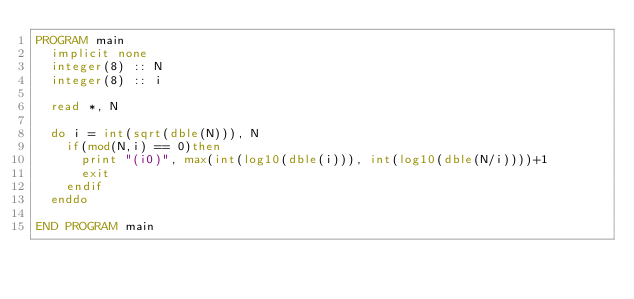Convert code to text. <code><loc_0><loc_0><loc_500><loc_500><_FORTRAN_>PROGRAM main
  implicit none
  integer(8) :: N
  integer(8) :: i
  
  read *, N
  
  do i = int(sqrt(dble(N))), N
    if(mod(N,i) == 0)then
      print "(i0)", max(int(log10(dble(i))), int(log10(dble(N/i))))+1
      exit
    endif
  enddo

END PROGRAM main</code> 